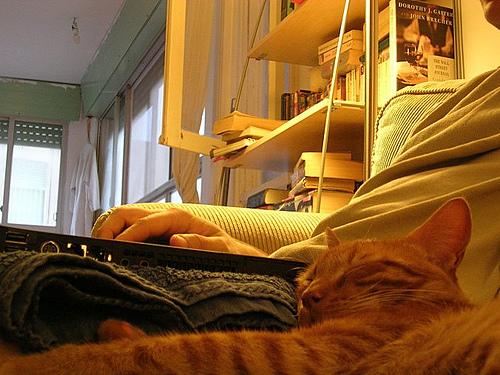Is this cat's eyes closed or open?
Keep it brief. Closed. Is this cat leaning on a human?
Write a very short answer. Yes. Is the cat relaxed?
Short answer required. Yes. 